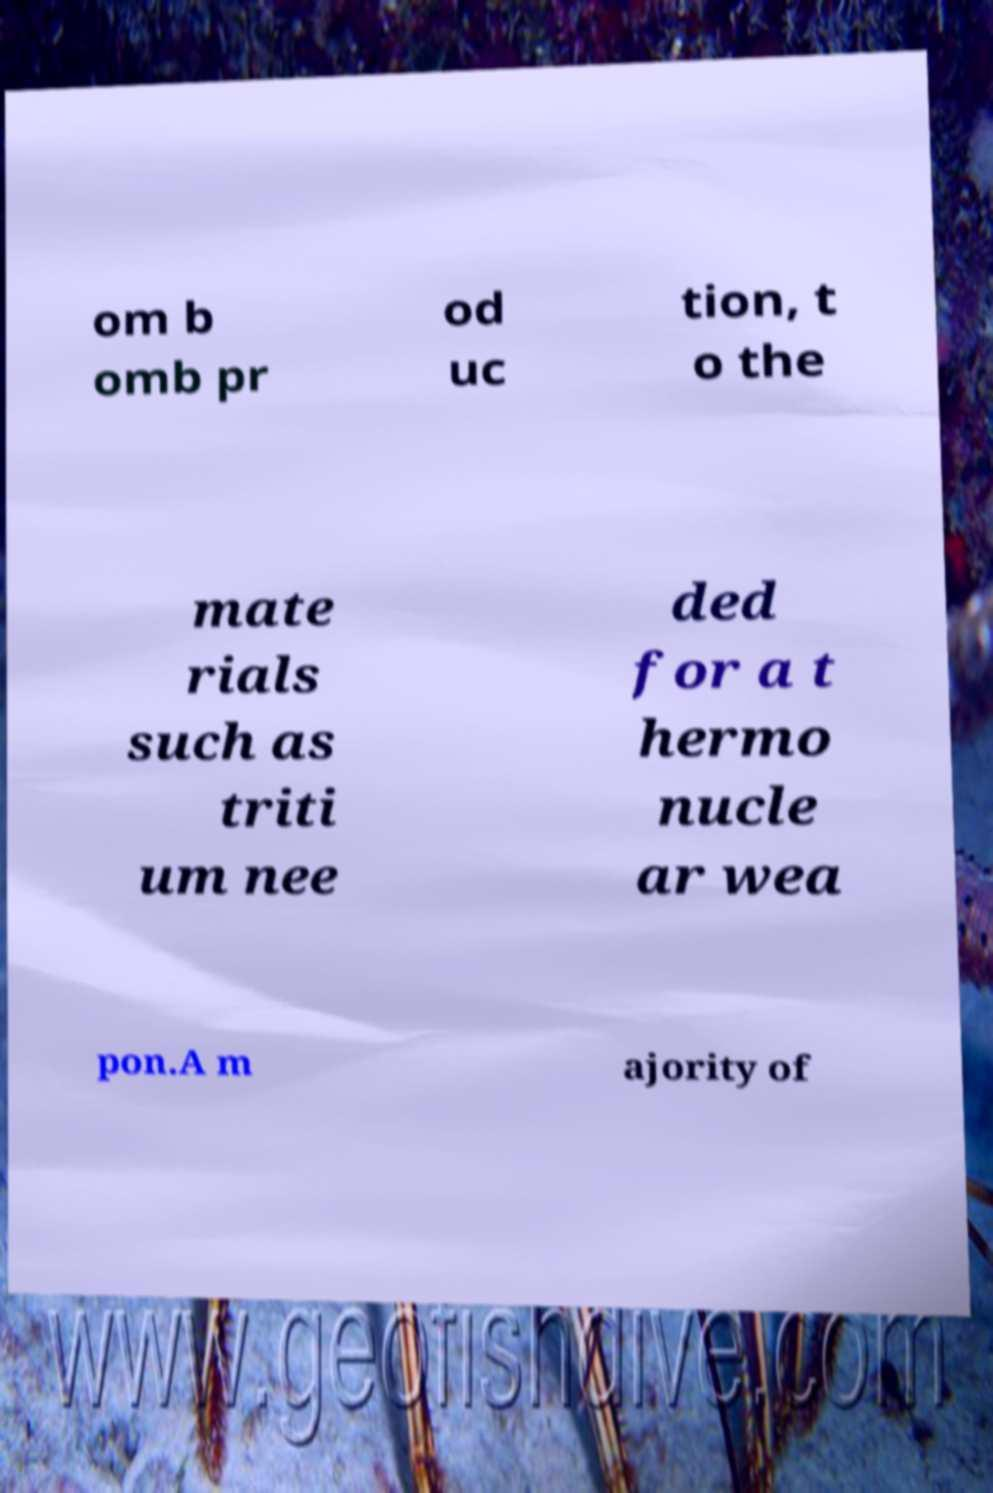Could you assist in decoding the text presented in this image and type it out clearly? om b omb pr od uc tion, t o the mate rials such as triti um nee ded for a t hermo nucle ar wea pon.A m ajority of 